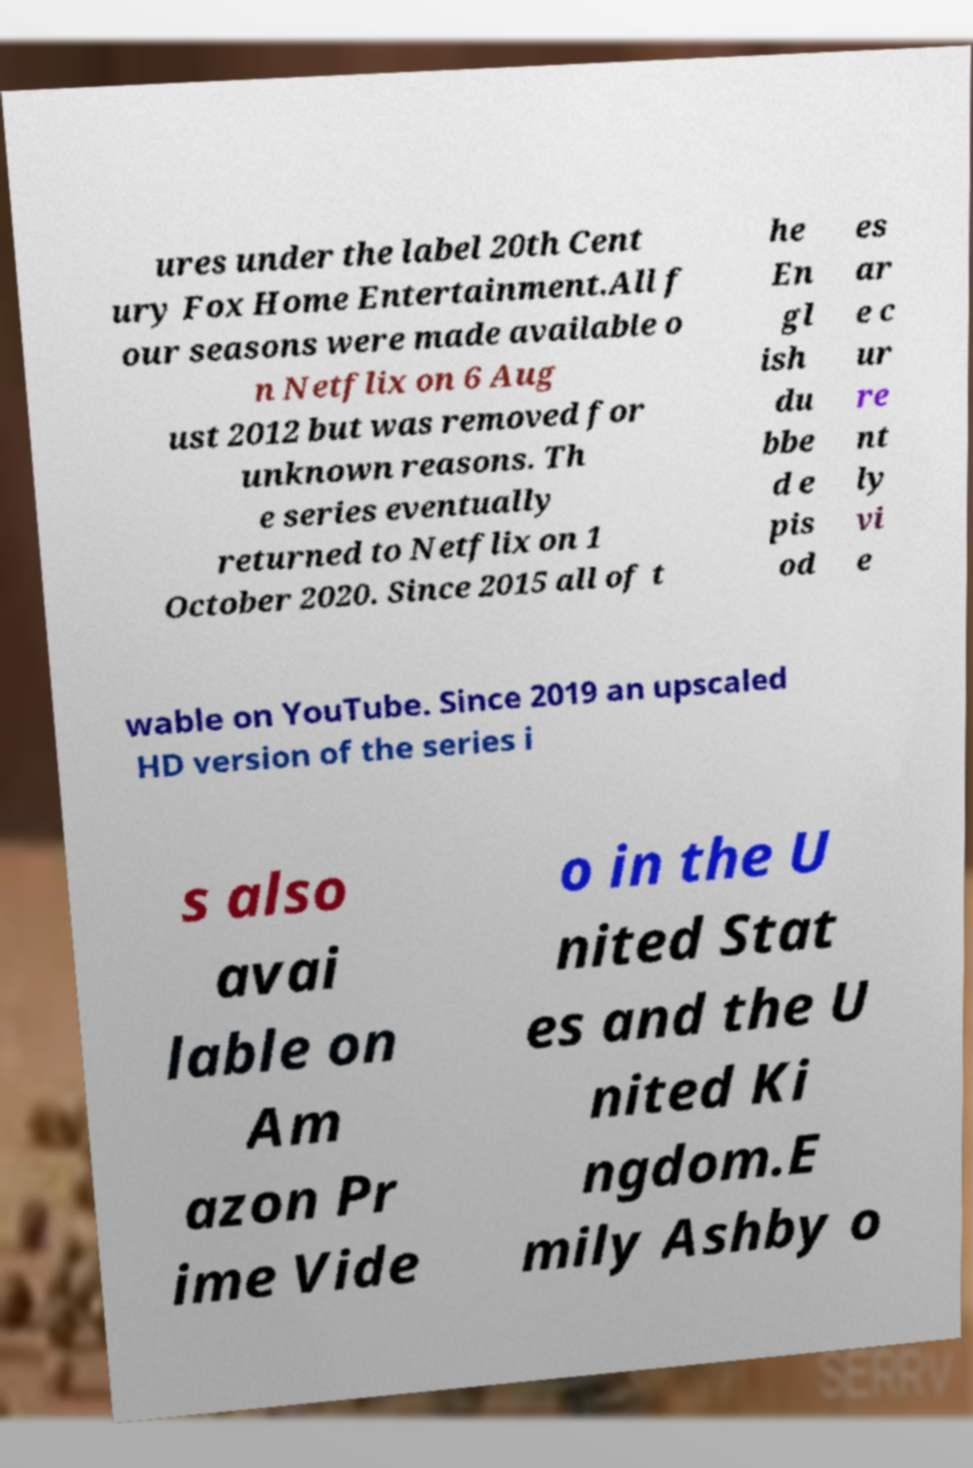Can you read and provide the text displayed in the image?This photo seems to have some interesting text. Can you extract and type it out for me? ures under the label 20th Cent ury Fox Home Entertainment.All f our seasons were made available o n Netflix on 6 Aug ust 2012 but was removed for unknown reasons. Th e series eventually returned to Netflix on 1 October 2020. Since 2015 all of t he En gl ish du bbe d e pis od es ar e c ur re nt ly vi e wable on YouTube. Since 2019 an upscaled HD version of the series i s also avai lable on Am azon Pr ime Vide o in the U nited Stat es and the U nited Ki ngdom.E mily Ashby o 